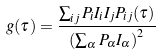Convert formula to latex. <formula><loc_0><loc_0><loc_500><loc_500>g ( \tau ) = \frac { \sum _ { i j } P _ { i } I _ { i } I _ { j } P _ { i j } ( \tau ) } { \left ( \sum _ { \alpha } P _ { \alpha } I _ { \alpha } \right ) ^ { 2 } }</formula> 